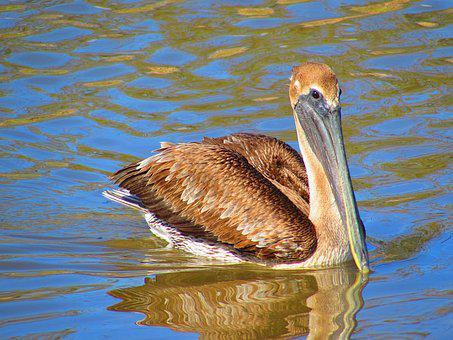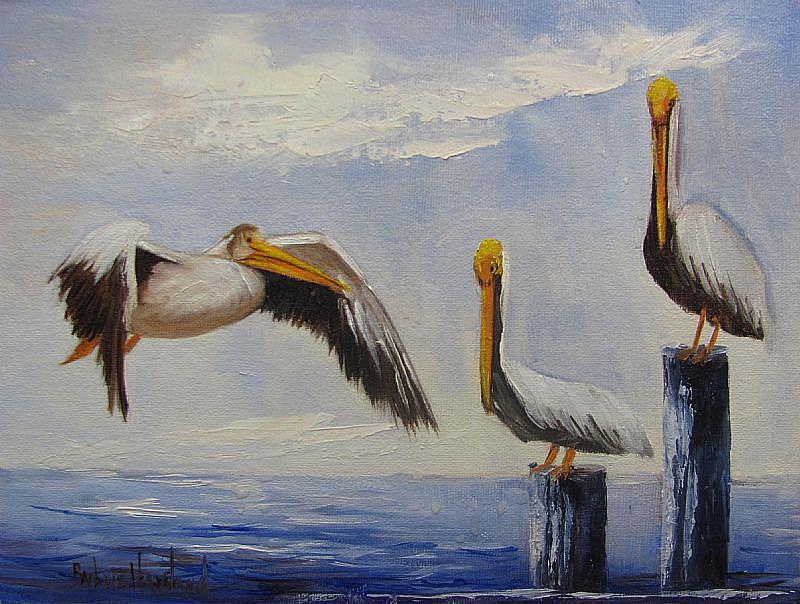The first image is the image on the left, the second image is the image on the right. Evaluate the accuracy of this statement regarding the images: "Three birds are standing on posts in water in the image on the left.". Is it true? Answer yes or no. No. The first image is the image on the left, the second image is the image on the right. Given the left and right images, does the statement "Three pelicans perch on wood posts in the water in the left image." hold true? Answer yes or no. No. 